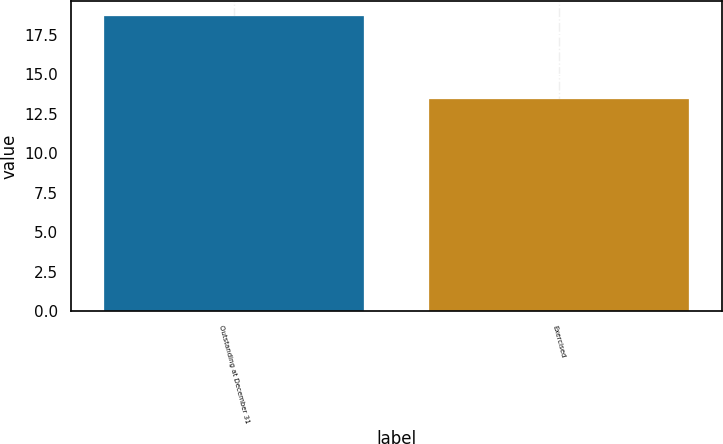<chart> <loc_0><loc_0><loc_500><loc_500><bar_chart><fcel>Outstanding at December 31<fcel>Exercised<nl><fcel>18.68<fcel>13.43<nl></chart> 